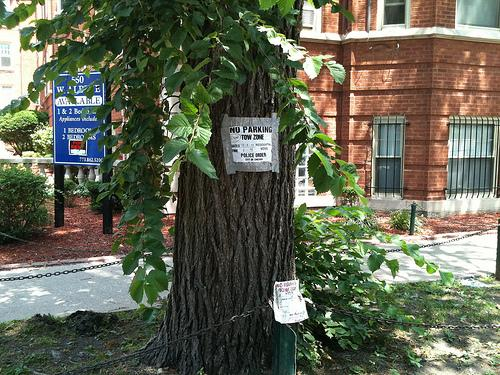Identify the primary object in the image and describe its color and general appearance. The primary object is a tree trunk with dark brown bark, featuring black grooves and green foliage growing on it. What is the purpose of the blue and white sign in the image, and what are its colors? The blue and white sign is a real estate sign about housing, featuring blue and white colors. Identify any security features found on the building's windows and describe their appearance. The building's windows have iron bars and burglar bars for security, covering the entire window frame. Analyze the sidewalk in the image and describe where it is situated relative to the tree. The sidewalk is situated behind the tree and extends along its length, with a chain fence bordering it. What type of sign is found on the tree and how is it attached? A no parking sign is found on the tree, attached using duct tape. What type of sign is hanging on the tree, and what does it prohibit? A square white no parking sign is hanging on the tree, prohibiting parking in the area. Explain the appearance and purpose of the fence in front of the building. The fence is made of black chains and posts, serving as a barrier along the street and sidewalk behind the tree. What type of foliage is seen growing on the tree, and where is it positioned? Bushy leaves are growing on the right side of the tree, along with branches growing down the trunk and by the tree's side. Provide a brief description of the building in the image, including its construction material and any notable features. The building is made of red and white bricks, has white windows, is fenced with iron bars, and has a rough texture and lines in its brickwork. Describe the characteristics of the window in the image, including its color, size, and protective features. The window is white, square-shaped, and medium-sized, with metal bars covering it for protection. What is the text on the large blue sign? For rent Is there a real estate sign in the image? Yes, there is a real estate sign. Look for a grey cat sitting on the window sill of the brick building. It seems to be watching the people walking by on the sidewalk. No, it's not mentioned in the image. Identify the texture of the tree trunk. Rough Describe the sign attached to the tree with grey tape. The sign is a square, white no parking sign attached to the tree with grey duct tape. Describe the greenery on the right side of the tree. There is a bush with dense foliage on the right side of the tree. Write a caption describing the foliage on the tree. Green, bushy leaves are growing on the tree. Choose the correct description for the window of the building. A) Red and white bricks B) Metal bars covering the window C) Green foliage growing around it  B) Metal bars covering the window Detect the type of fence around the tree. The tree is fenced with a chain. Determine the color of the street sign. Blue Count the number of captions describing signs on a tree. 8 Which sign has red words on it? The real estate sign has red words on it. Which object is next to the sidewalk? Tree Describe the bluish sign's size. The blue and white sign is large. Locate a sign that has been taped to an object. The no parking sign is taped to a tree trunk. Find the sign held up by the duct tape. The no parking sign is held up by duct tape. What is the color of the tree trunk? Dark brown Which object has a rough texture? The tree trunk Identify the type of bricks used in the building. Red and white bricks Explain the structure of the black chain fence. The fence is made of long, linked black chains. 